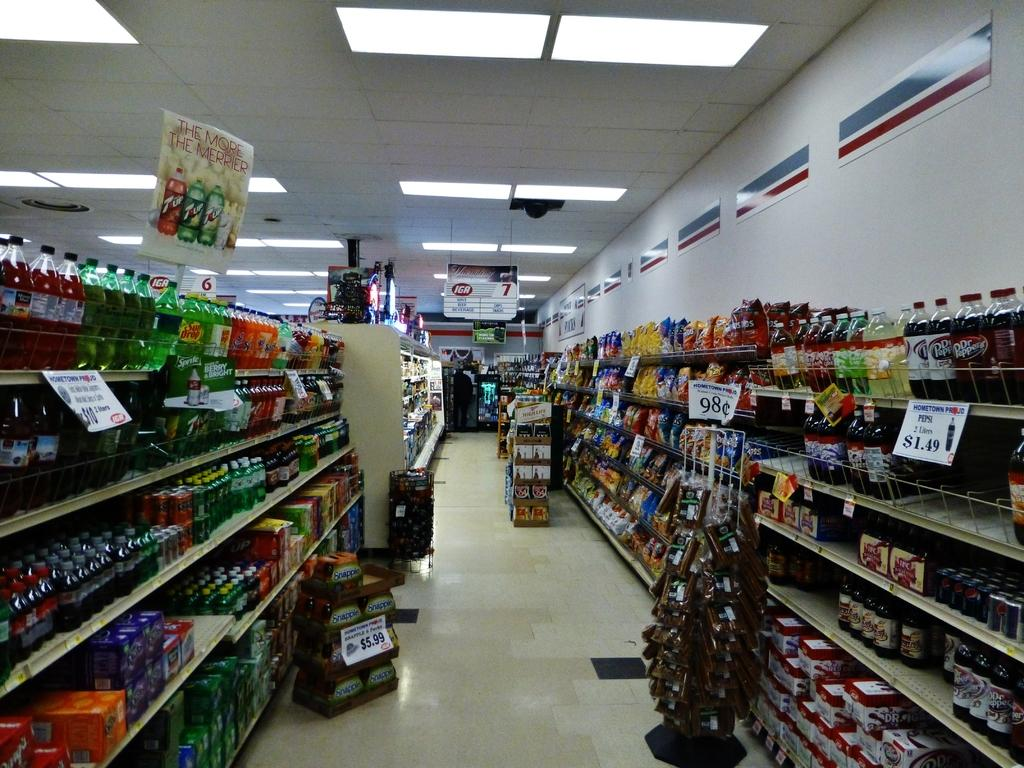Provide a one-sentence caption for the provided image. A beverage grocery store aisle with a sign for Pepsi for $1.49. 